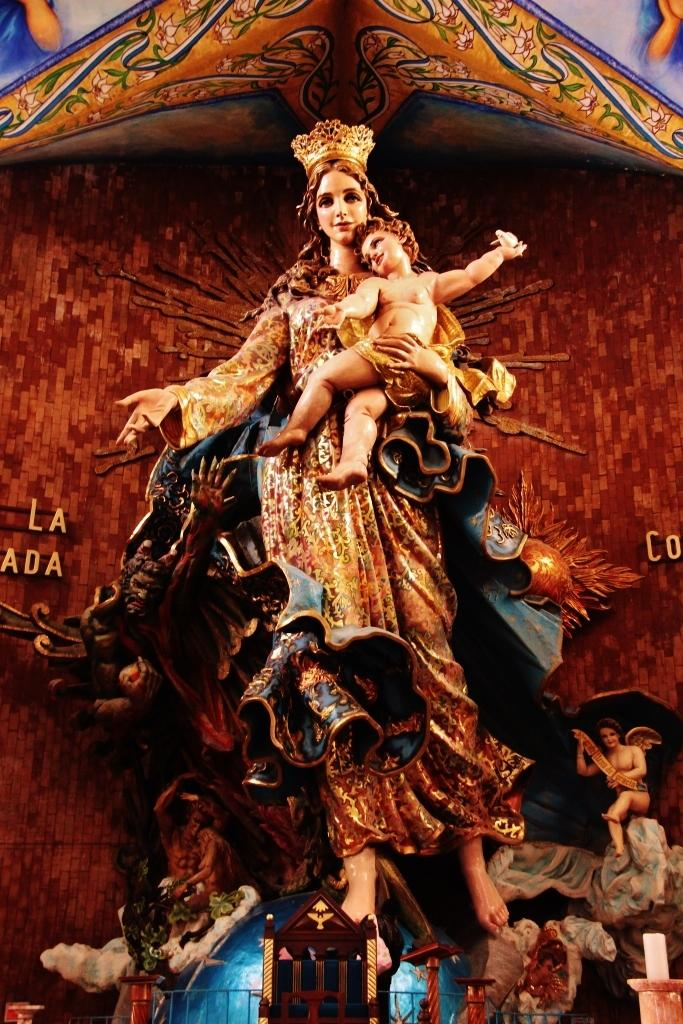What objects are present in the image? There are statues in the image. What is the color of the statues? The statues are brown in color. What colors can be seen in the background of the image? The background of the image includes brown, white, and blue colors. What type of music can be heard playing in the room in the image? There is no room or music present in the image; it only features statues and their colors. 